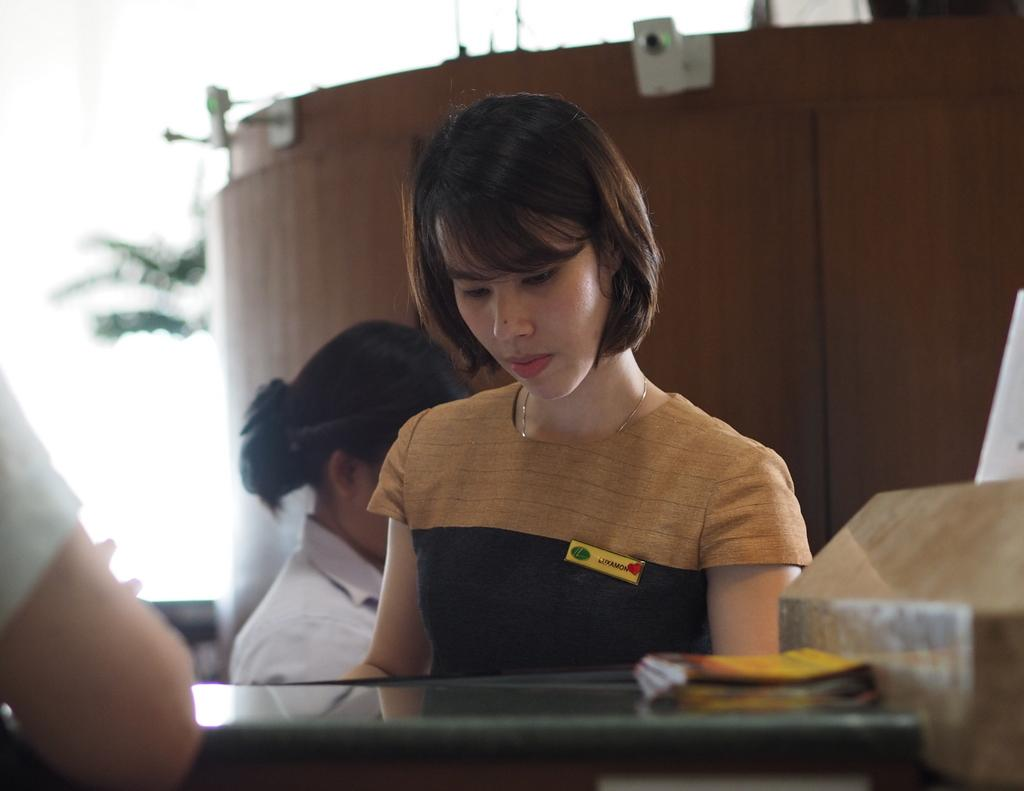Who is present in the image? There are people in the image. Can you describe one of the individuals in the image? There is a woman in the image. What object can be seen on a table in the image? There is a book on a table in the image. Where is the book located in relation to the woman? The book is in front of the woman. What can be seen in the background of the image? There are plants in the background of the image. What color is the sweater worn by the egg in the image? There is no egg or sweater present in the image. Can you tell me how many mailboxes are visible in the image? There are no mailboxes visible in the image. 